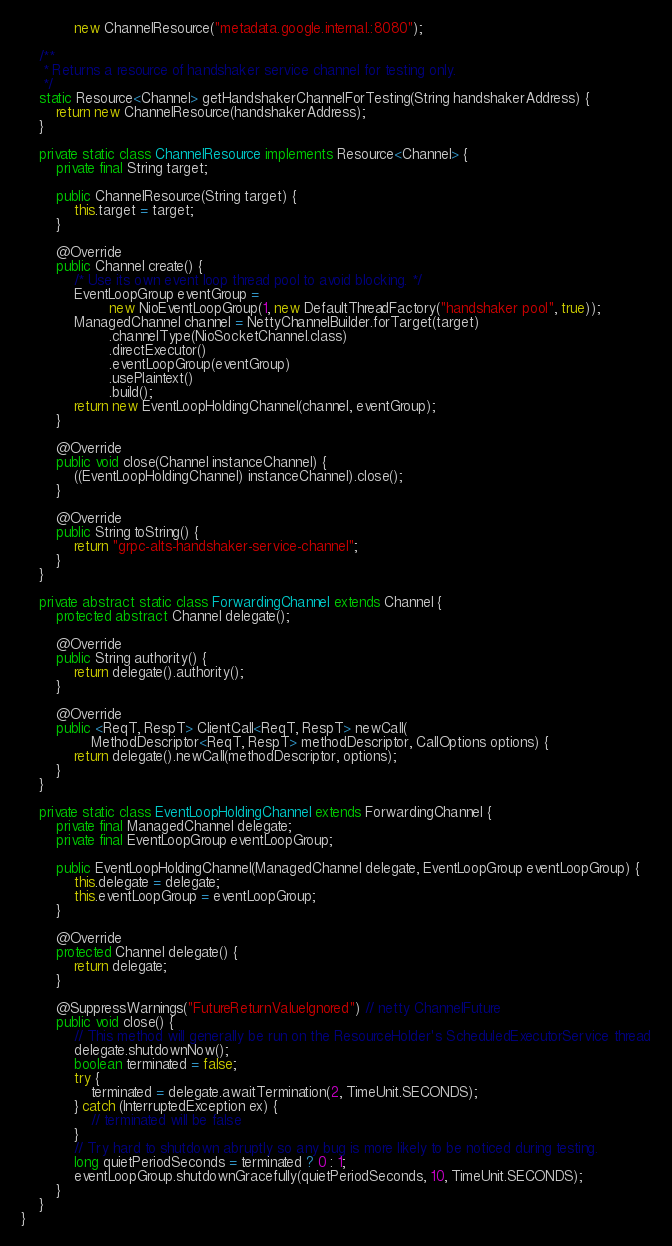Convert code to text. <code><loc_0><loc_0><loc_500><loc_500><_Java_>            new ChannelResource("metadata.google.internal.:8080");

    /**
     * Returns a resource of handshaker service channel for testing only.
     */
    static Resource<Channel> getHandshakerChannelForTesting(String handshakerAddress) {
        return new ChannelResource(handshakerAddress);
    }

    private static class ChannelResource implements Resource<Channel> {
        private final String target;

        public ChannelResource(String target) {
            this.target = target;
        }

        @Override
        public Channel create() {
            /* Use its own event loop thread pool to avoid blocking. */
            EventLoopGroup eventGroup =
                    new NioEventLoopGroup(1, new DefaultThreadFactory("handshaker pool", true));
            ManagedChannel channel = NettyChannelBuilder.forTarget(target)
                    .channelType(NioSocketChannel.class)
                    .directExecutor()
                    .eventLoopGroup(eventGroup)
                    .usePlaintext()
                    .build();
            return new EventLoopHoldingChannel(channel, eventGroup);
        }

        @Override
        public void close(Channel instanceChannel) {
            ((EventLoopHoldingChannel) instanceChannel).close();
        }

        @Override
        public String toString() {
            return "grpc-alts-handshaker-service-channel";
        }
    }

    private abstract static class ForwardingChannel extends Channel {
        protected abstract Channel delegate();

        @Override
        public String authority() {
            return delegate().authority();
        }

        @Override
        public <ReqT, RespT> ClientCall<ReqT, RespT> newCall(
                MethodDescriptor<ReqT, RespT> methodDescriptor, CallOptions options) {
            return delegate().newCall(methodDescriptor, options);
        }
    }

    private static class EventLoopHoldingChannel extends ForwardingChannel {
        private final ManagedChannel delegate;
        private final EventLoopGroup eventLoopGroup;

        public EventLoopHoldingChannel(ManagedChannel delegate, EventLoopGroup eventLoopGroup) {
            this.delegate = delegate;
            this.eventLoopGroup = eventLoopGroup;
        }

        @Override
        protected Channel delegate() {
            return delegate;
        }

        @SuppressWarnings("FutureReturnValueIgnored") // netty ChannelFuture
        public void close() {
            // This method will generally be run on the ResourceHolder's ScheduledExecutorService thread
            delegate.shutdownNow();
            boolean terminated = false;
            try {
                terminated = delegate.awaitTermination(2, TimeUnit.SECONDS);
            } catch (InterruptedException ex) {
                // terminated will be false
            }
            // Try hard to shutdown abruptly so any bug is more likely to be noticed during testing.
            long quietPeriodSeconds = terminated ? 0 : 1;
            eventLoopGroup.shutdownGracefully(quietPeriodSeconds, 10, TimeUnit.SECONDS);
        }
    }
}
</code> 